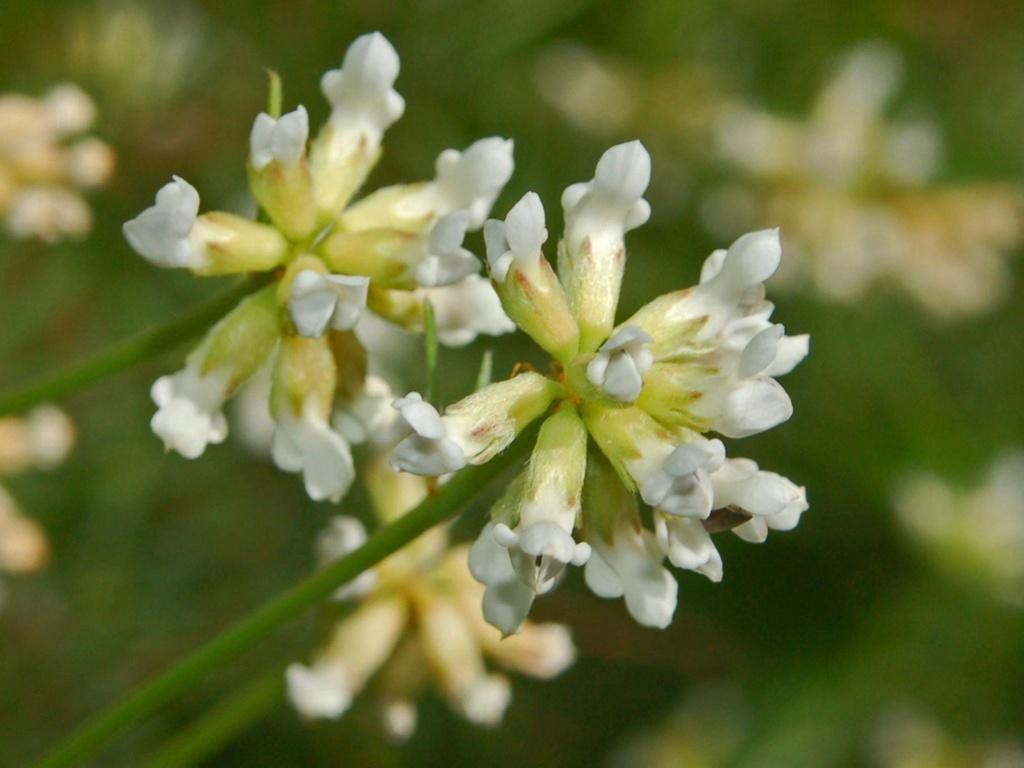What type of flowers can be seen in the image? There are white-colored flowers in the image. Where are the flowers located? The flowers are on a plant. What type of hat is the plant wearing in the image? There is no hat present in the image; it is a plant with white flowers. What type of pot is the plant growing in within the image? There is no pot visible in the image; the plant with white flowers is not shown in a pot. 